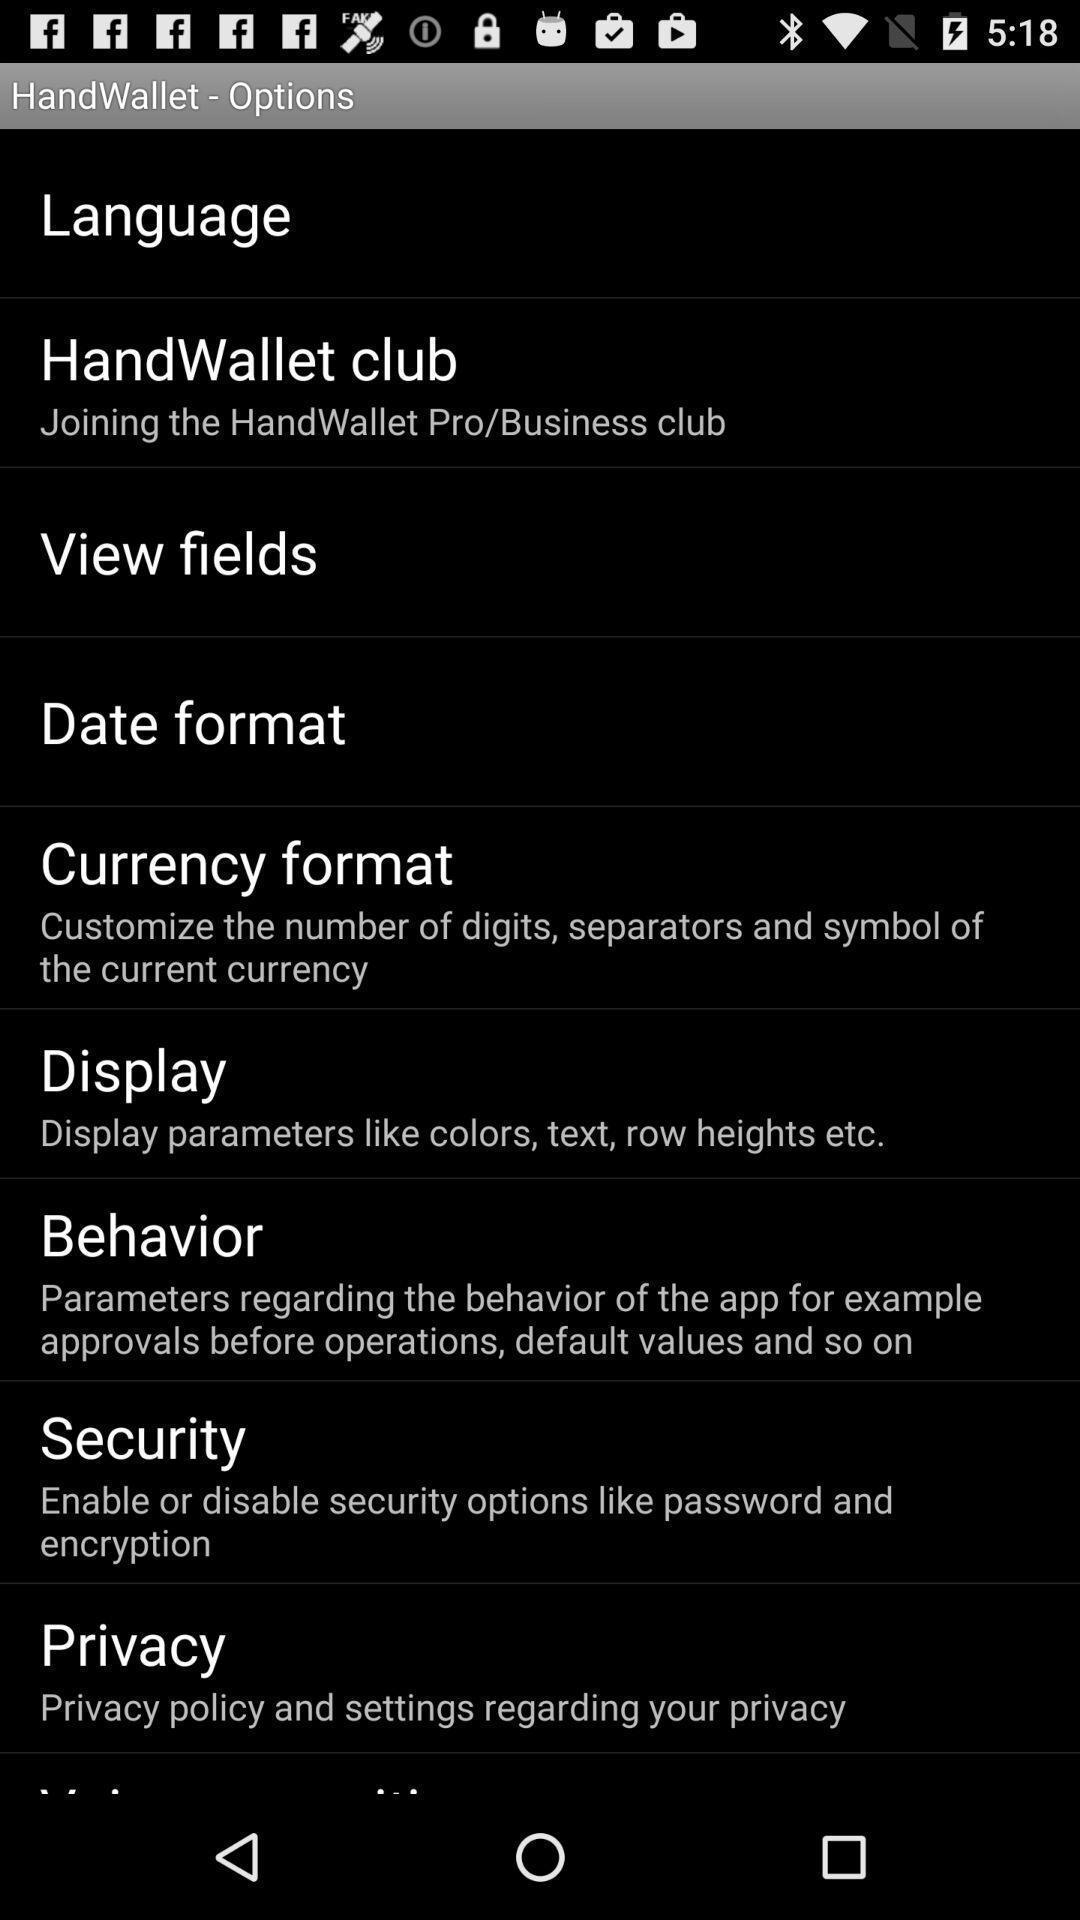Summarize the information in this screenshot. Screen displaying the multiple options. 